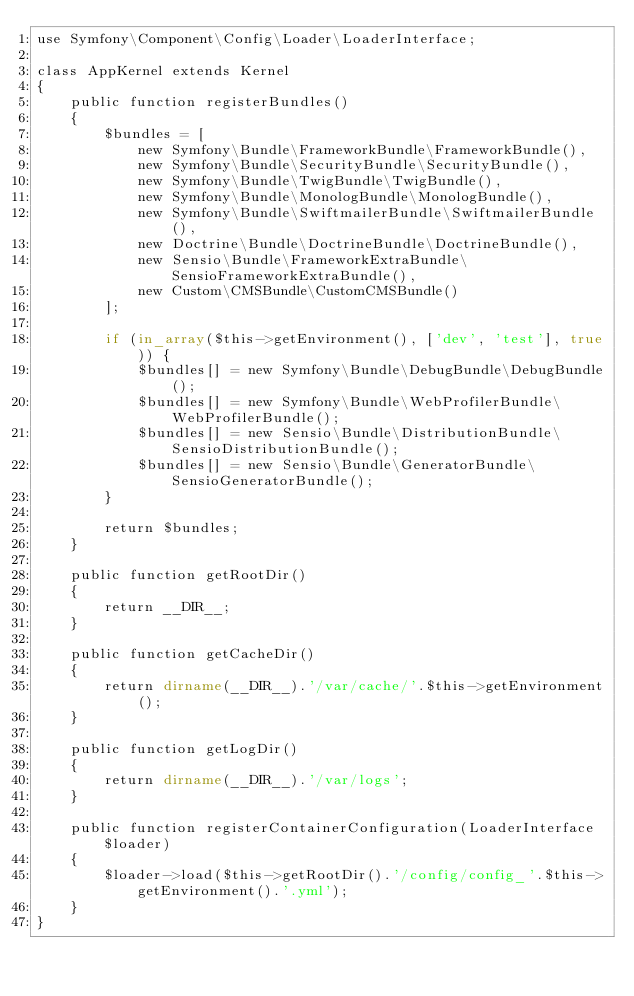<code> <loc_0><loc_0><loc_500><loc_500><_PHP_>use Symfony\Component\Config\Loader\LoaderInterface;

class AppKernel extends Kernel
{
    public function registerBundles()
    {
        $bundles = [
            new Symfony\Bundle\FrameworkBundle\FrameworkBundle(),
            new Symfony\Bundle\SecurityBundle\SecurityBundle(),
            new Symfony\Bundle\TwigBundle\TwigBundle(),
            new Symfony\Bundle\MonologBundle\MonologBundle(),
            new Symfony\Bundle\SwiftmailerBundle\SwiftmailerBundle(),
            new Doctrine\Bundle\DoctrineBundle\DoctrineBundle(),
            new Sensio\Bundle\FrameworkExtraBundle\SensioFrameworkExtraBundle(),
            new Custom\CMSBundle\CustomCMSBundle()
        ];

        if (in_array($this->getEnvironment(), ['dev', 'test'], true)) {
            $bundles[] = new Symfony\Bundle\DebugBundle\DebugBundle();
            $bundles[] = new Symfony\Bundle\WebProfilerBundle\WebProfilerBundle();
            $bundles[] = new Sensio\Bundle\DistributionBundle\SensioDistributionBundle();
            $bundles[] = new Sensio\Bundle\GeneratorBundle\SensioGeneratorBundle();
        }

        return $bundles;
    }

    public function getRootDir()
    {
        return __DIR__;
    }

    public function getCacheDir()
    {
        return dirname(__DIR__).'/var/cache/'.$this->getEnvironment();
    }

    public function getLogDir()
    {
        return dirname(__DIR__).'/var/logs';
    }

    public function registerContainerConfiguration(LoaderInterface $loader)
    {
        $loader->load($this->getRootDir().'/config/config_'.$this->getEnvironment().'.yml');
    }
}
</code> 